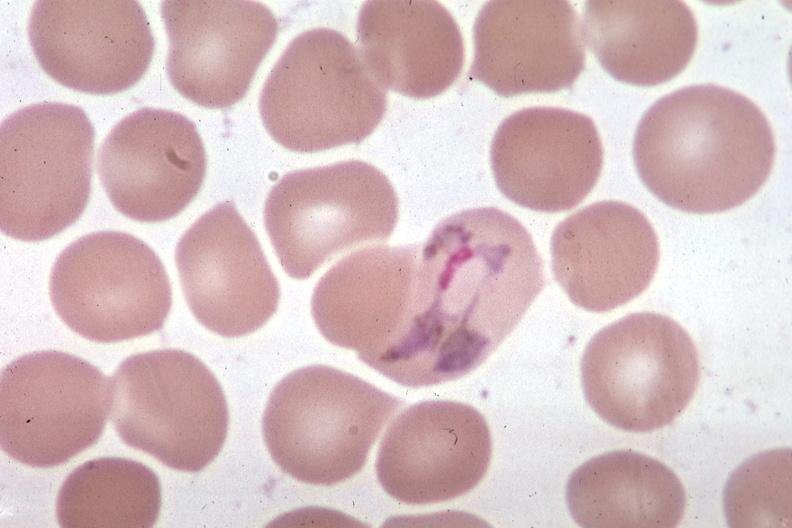s arcus senilis present?
Answer the question using a single word or phrase. No 